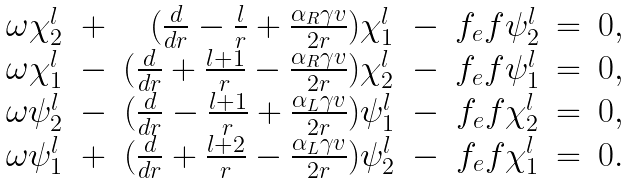<formula> <loc_0><loc_0><loc_500><loc_500>\begin{array} { r c r c r c l } { { \omega \chi _ { 2 } ^ { l } } } & { + } & { { ( \frac { d } { d r } - \frac { l } { r } + \frac { \alpha _ { R } \gamma v } { 2 r } ) \chi _ { 1 } ^ { l } } } & { - } & { { f _ { e } f \psi _ { 2 } ^ { l } } } & { = } & { 0 , } \\ { { \omega \chi _ { 1 } ^ { l } } } & { - } & { { ( \frac { d } { d r } + \frac { l + 1 } { r } - \frac { \alpha _ { R } \gamma v } { 2 r } ) \chi _ { 2 } ^ { l } } } & { - } & { { f _ { e } f \psi _ { 1 } ^ { l } } } & { = } & { 0 , } \\ { { \omega \psi _ { 2 } ^ { l } } } & { - } & { { ( \frac { d } { d r } - \frac { l + 1 } { r } + \frac { \alpha _ { L } \gamma v } { 2 r } ) \psi _ { 1 } ^ { l } } } & { - } & { { f _ { e } f \chi _ { 2 } ^ { l } } } & { = } & { 0 , } \\ { { \omega \psi _ { 1 } ^ { l } } } & { + } & { { ( \frac { d } { d r } + \frac { l + 2 } { r } - \frac { \alpha _ { L } \gamma v } { 2 r } ) \psi _ { 2 } ^ { l } } } & { - } & { { f _ { e } f \chi _ { 1 } ^ { l } } } & { = } & { 0 . } \end{array}</formula> 